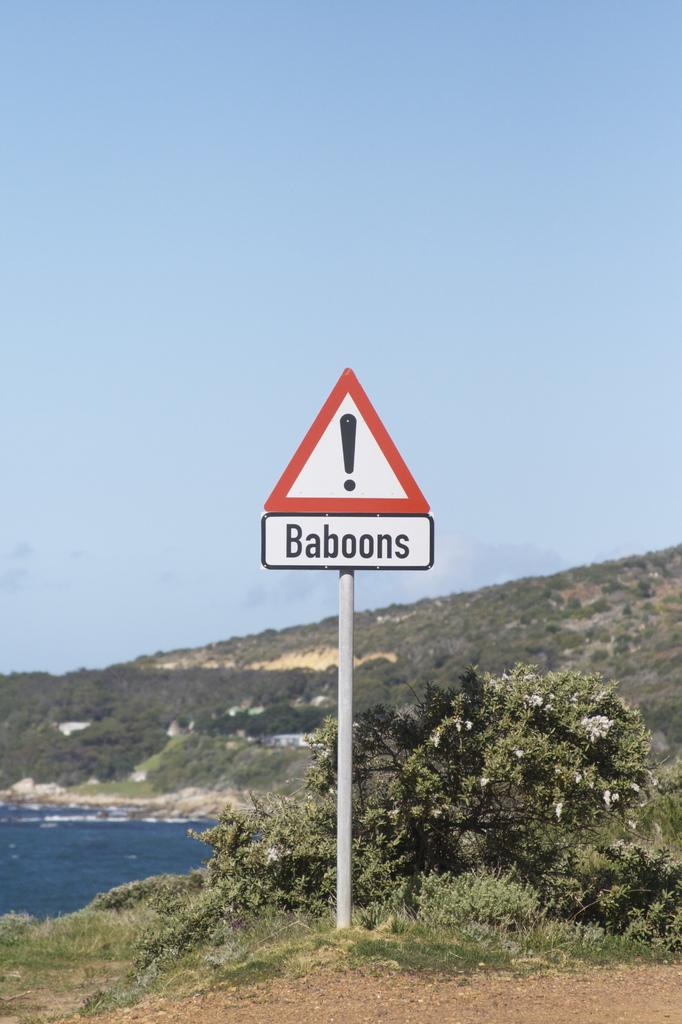<image>
Create a compact narrative representing the image presented. A sign by the ocean that says Baboons. 